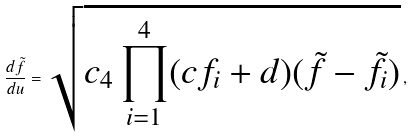Convert formula to latex. <formula><loc_0><loc_0><loc_500><loc_500>\frac { d \tilde { f } } { d u } = \sqrt { c _ { 4 } \prod _ { i = 1 } ^ { 4 } ( c f _ { i } + d ) ( \tilde { f } - \tilde { f } _ { i } ) } \, ,</formula> 